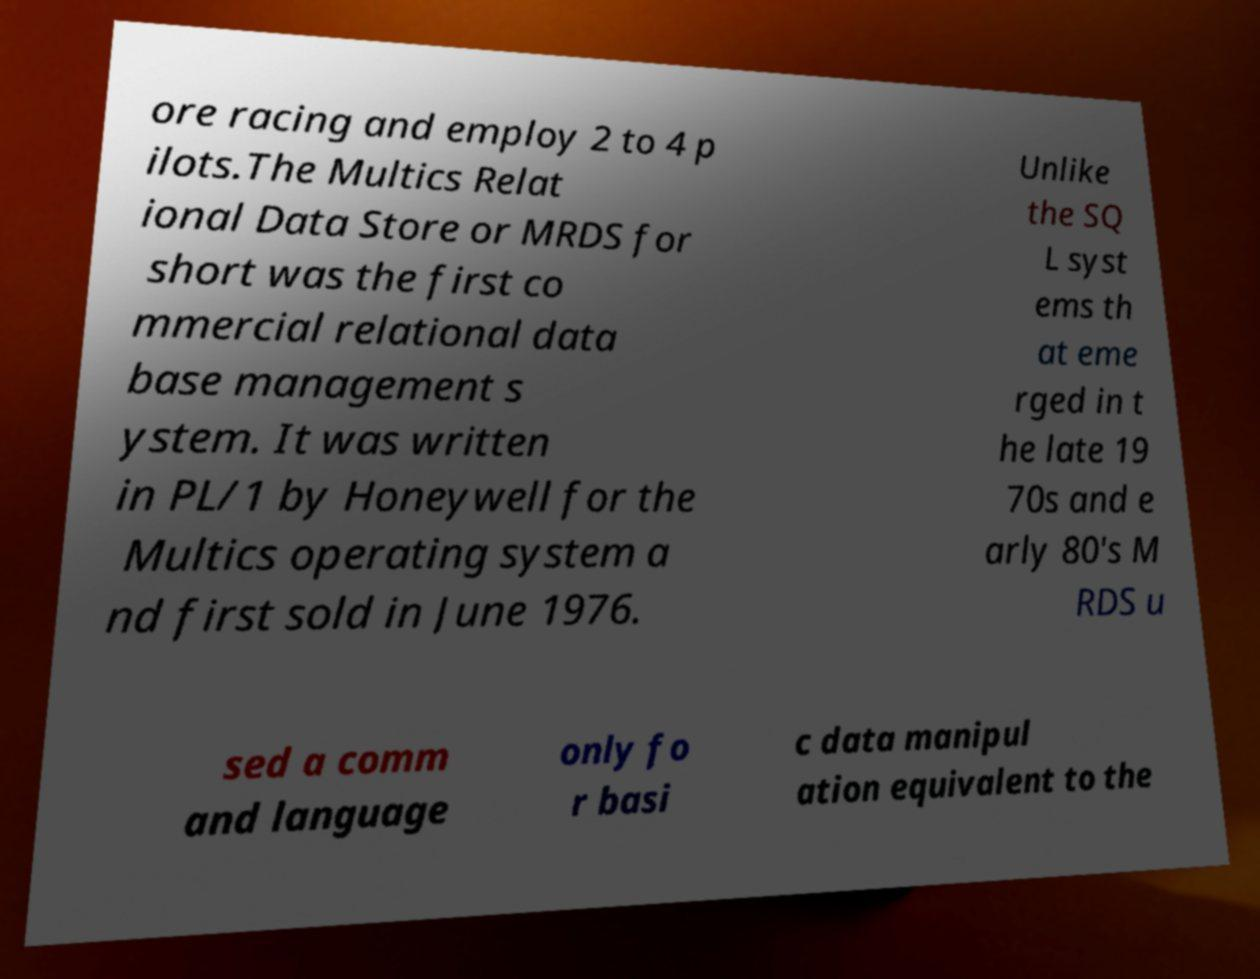Can you accurately transcribe the text from the provided image for me? ore racing and employ 2 to 4 p ilots.The Multics Relat ional Data Store or MRDS for short was the first co mmercial relational data base management s ystem. It was written in PL/1 by Honeywell for the Multics operating system a nd first sold in June 1976. Unlike the SQ L syst ems th at eme rged in t he late 19 70s and e arly 80's M RDS u sed a comm and language only fo r basi c data manipul ation equivalent to the 